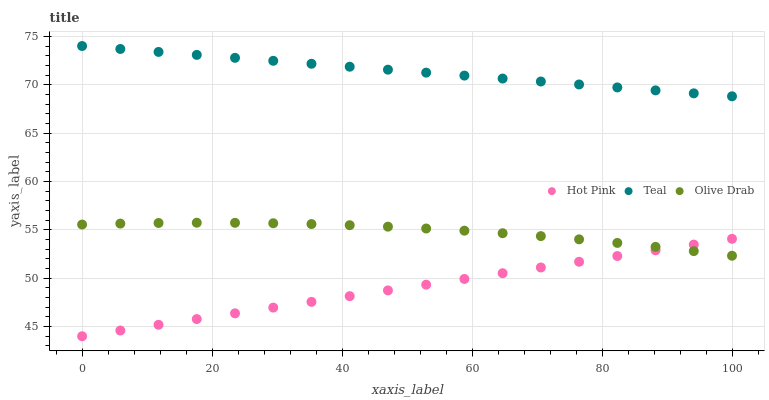Does Hot Pink have the minimum area under the curve?
Answer yes or no. Yes. Does Teal have the maximum area under the curve?
Answer yes or no. Yes. Does Olive Drab have the minimum area under the curve?
Answer yes or no. No. Does Olive Drab have the maximum area under the curve?
Answer yes or no. No. Is Hot Pink the smoothest?
Answer yes or no. Yes. Is Olive Drab the roughest?
Answer yes or no. Yes. Is Teal the smoothest?
Answer yes or no. No. Is Teal the roughest?
Answer yes or no. No. Does Hot Pink have the lowest value?
Answer yes or no. Yes. Does Olive Drab have the lowest value?
Answer yes or no. No. Does Teal have the highest value?
Answer yes or no. Yes. Does Olive Drab have the highest value?
Answer yes or no. No. Is Hot Pink less than Teal?
Answer yes or no. Yes. Is Teal greater than Hot Pink?
Answer yes or no. Yes. Does Hot Pink intersect Olive Drab?
Answer yes or no. Yes. Is Hot Pink less than Olive Drab?
Answer yes or no. No. Is Hot Pink greater than Olive Drab?
Answer yes or no. No. Does Hot Pink intersect Teal?
Answer yes or no. No. 